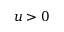Convert formula to latex. <formula><loc_0><loc_0><loc_500><loc_500>u > 0</formula> 